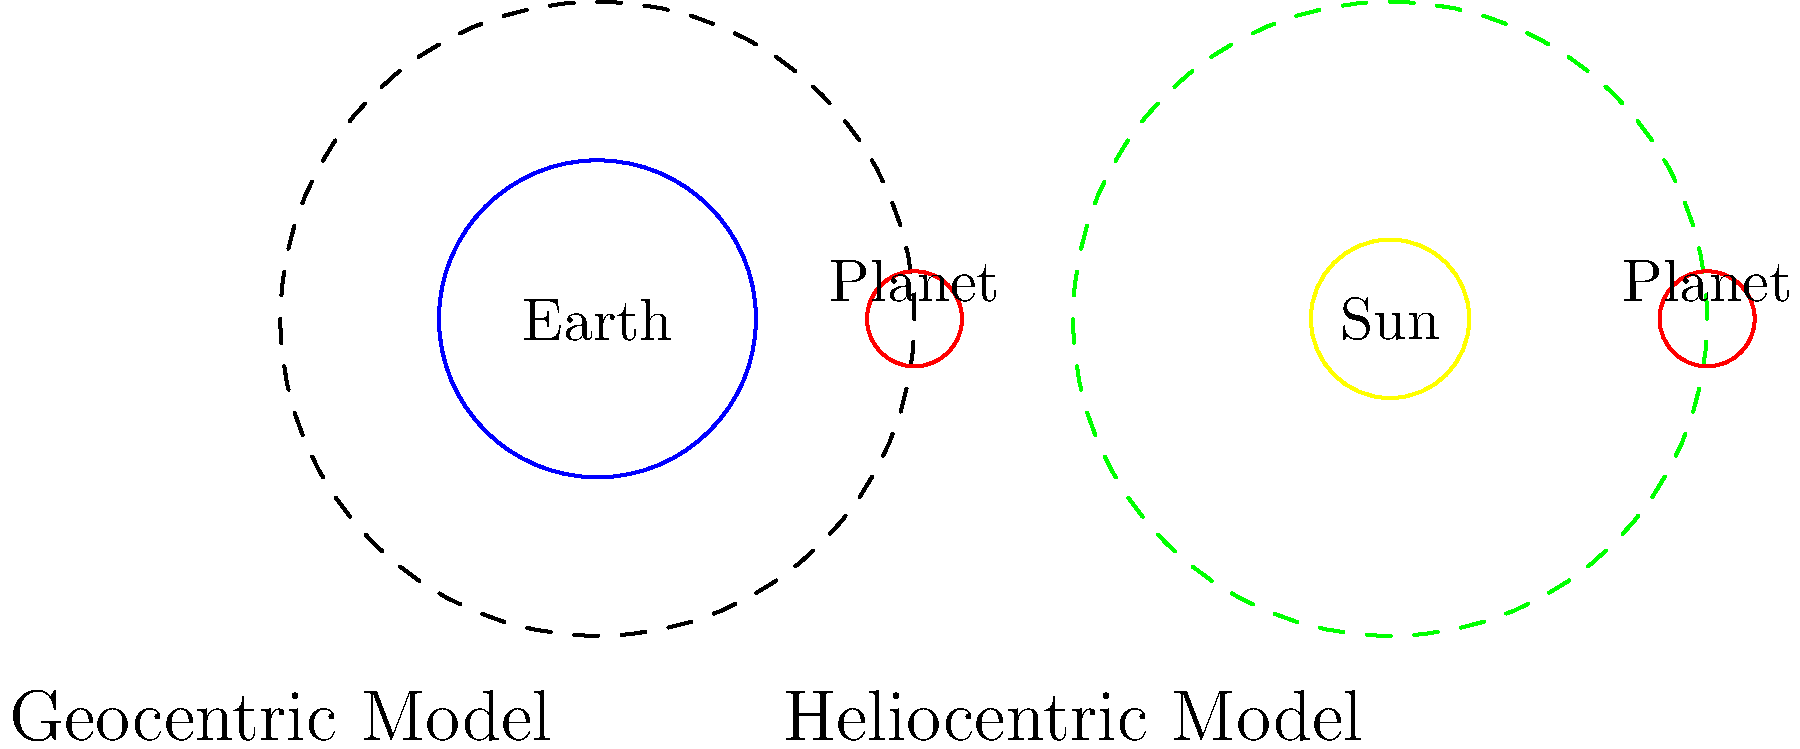Analyze the evolution of astronomical models from geocentric to heliocentric as depicted in the image. How did this shift in perspective influence the development of modern scientific thought during the Renaissance? 1. Geocentric Model:
   - Placed Earth at the center of the universe
   - Planets and Sun revolved around Earth
   - Supported by Ptolemy and accepted for centuries

2. Heliocentric Model:
   - Proposed by Copernicus during the Renaissance
   - Placed the Sun at the center with planets orbiting it
   - Simplified planetary motion explanations

3. Impact on scientific thought:
   - Challenged established beliefs and religious doctrine
   - Encouraged critical thinking and observation-based conclusions
   - Sparked the Scientific Revolution

4. Key figures:
   - Nicolaus Copernicus: Proposed the heliocentric model
   - Galileo Galilei: Provided observational evidence supporting heliocentrism
   - Johannes Kepler: Developed laws of planetary motion based on the heliocentric model

5. Long-term effects:
   - Promoted empirical research and mathematical modeling in science
   - Led to advancements in physics, mathematics, and astronomy
   - Influenced philosophy and the concept of human knowledge

6. Renaissance context:
   - Coincided with the revival of classical learning and humanism
   - Exemplified the spirit of inquiry and challenge to authority
   - Contributed to the broader intellectual and cultural transformation of Europe
Answer: The shift from geocentric to heliocentric models during the Renaissance challenged established beliefs, promoted empirical research, and sparked the Scientific Revolution, fundamentally reshaping modern scientific thought. 